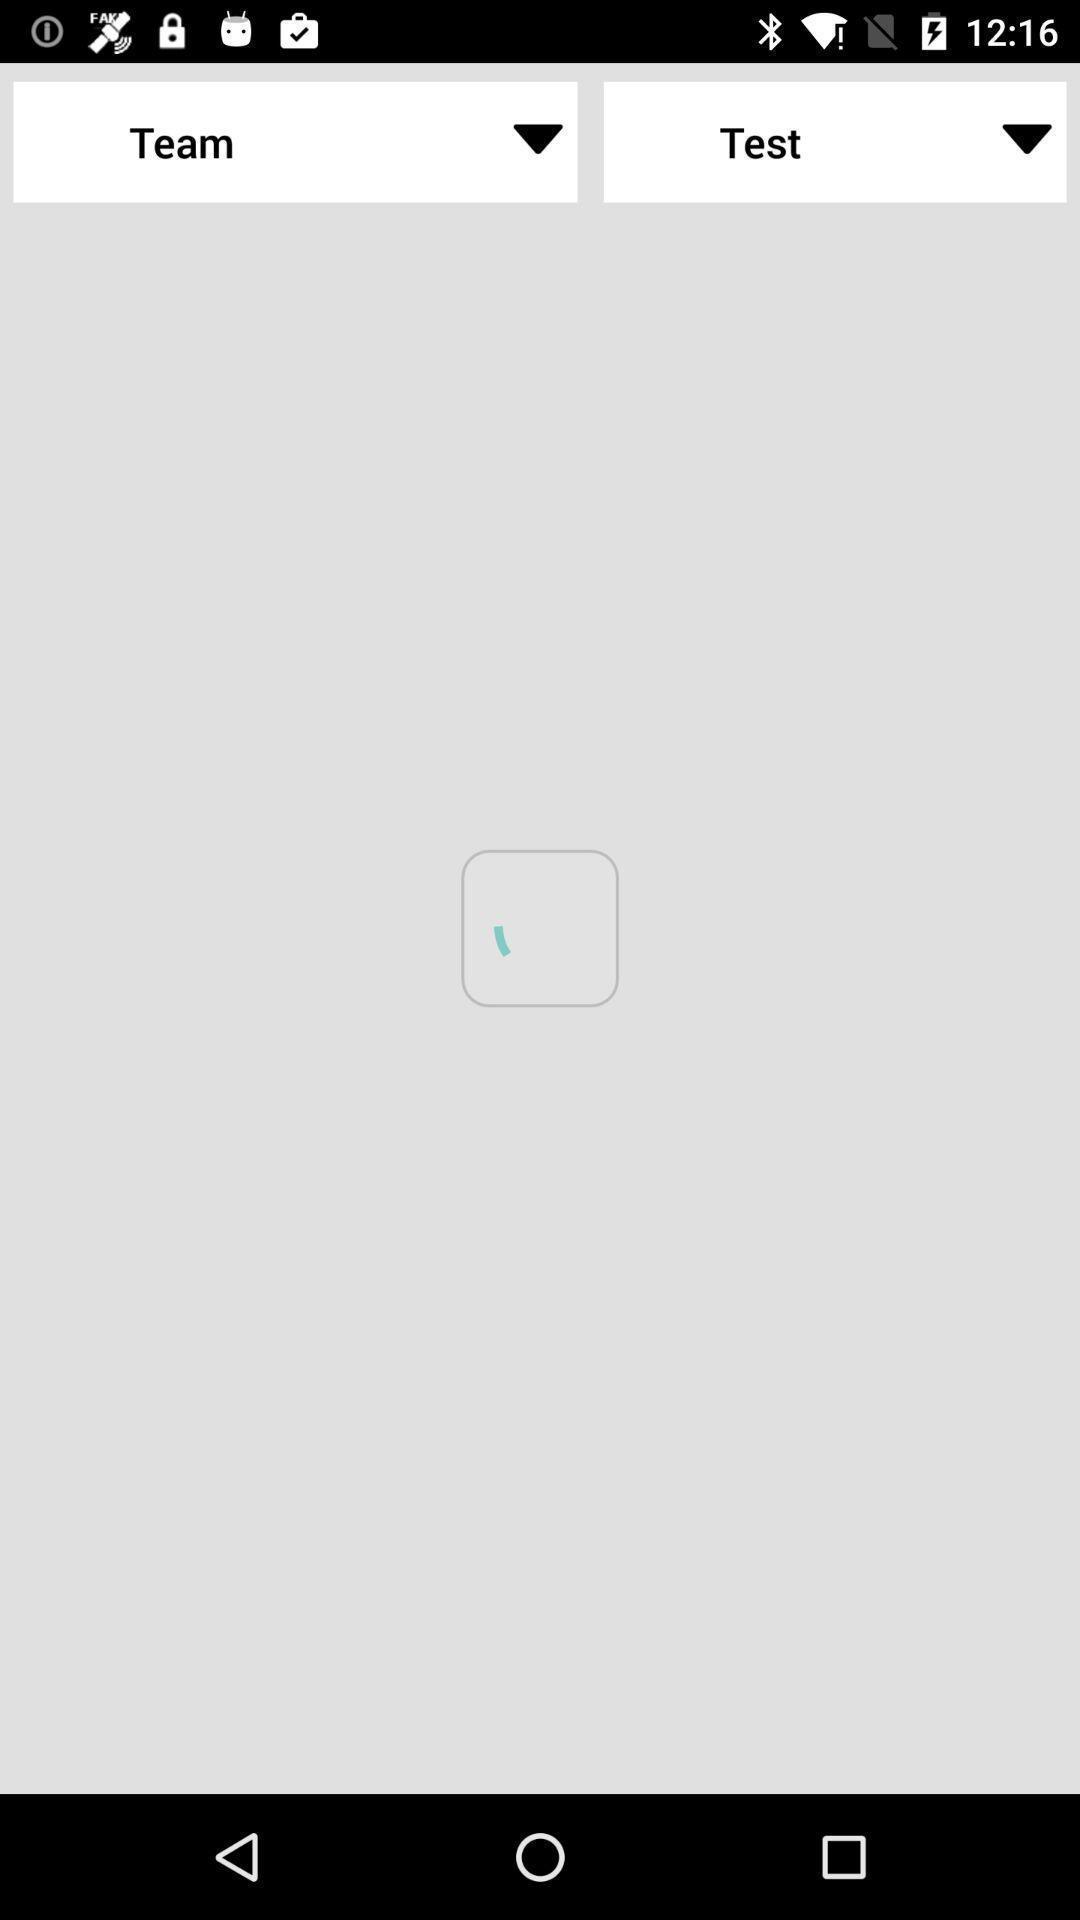What is the overall content of this screenshot? Screen displaying the blank page. 